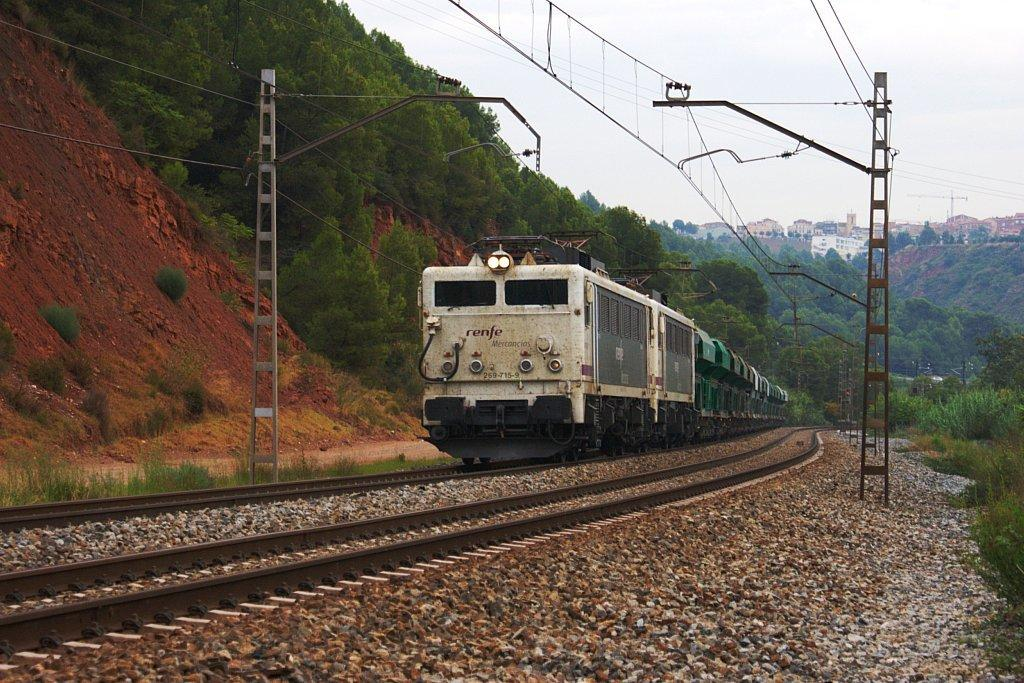What is located on the track in the image? There is a train on the track in the image. What can be seen in the image besides the train? There are poles, wires, plants, trees, houses, and the sky visible in the image. What type of vegetation is present in the image? There are plants and trees in the image. What is visible in the background of the image? There are houses and the sky visible in the background of the image. Where is the sister standing in the image? There is no sister present in the image. What type of attraction can be seen in the image? There is no attraction present in the image; it features a train on a track, poles, wires, plants, trees, houses, and the sky. 